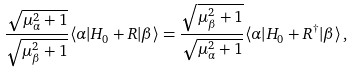Convert formula to latex. <formula><loc_0><loc_0><loc_500><loc_500>\frac { \sqrt { \mu ^ { 2 } _ { \alpha } + 1 } } { \sqrt { \mu ^ { 2 } _ { \beta } + 1 } } \langle \alpha | H _ { 0 } + R | \beta \rangle = \frac { \sqrt { \mu ^ { 2 } _ { \beta } + 1 } } { \sqrt { \mu ^ { 2 } _ { \alpha } + 1 } } \langle \alpha | H _ { 0 } + R ^ { \dagger } | \beta \rangle \, ,</formula> 